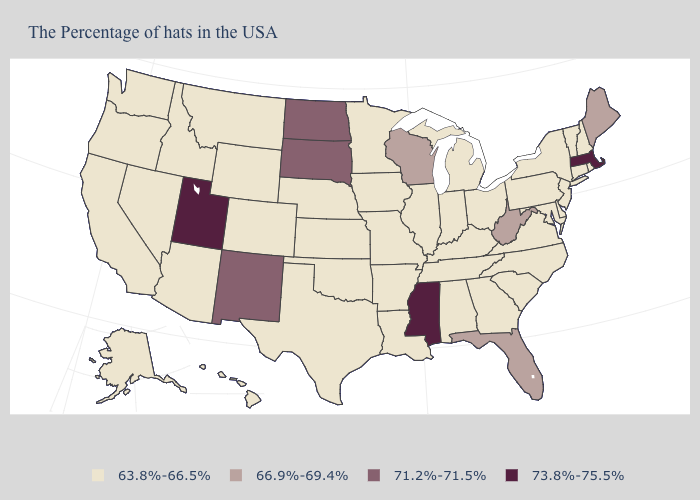What is the value of Nevada?
Quick response, please. 63.8%-66.5%. Name the states that have a value in the range 66.9%-69.4%?
Quick response, please. Maine, West Virginia, Florida, Wisconsin. Name the states that have a value in the range 66.9%-69.4%?
Short answer required. Maine, West Virginia, Florida, Wisconsin. Does New Mexico have the lowest value in the West?
Answer briefly. No. Does the map have missing data?
Quick response, please. No. Name the states that have a value in the range 71.2%-71.5%?
Be succinct. South Dakota, North Dakota, New Mexico. Name the states that have a value in the range 71.2%-71.5%?
Write a very short answer. South Dakota, North Dakota, New Mexico. Does the first symbol in the legend represent the smallest category?
Quick response, please. Yes. What is the lowest value in states that border New Mexico?
Short answer required. 63.8%-66.5%. Among the states that border Rhode Island , which have the highest value?
Write a very short answer. Massachusetts. Is the legend a continuous bar?
Be succinct. No. What is the value of South Dakota?
Keep it brief. 71.2%-71.5%. Name the states that have a value in the range 73.8%-75.5%?
Concise answer only. Massachusetts, Mississippi, Utah. What is the value of Nevada?
Keep it brief. 63.8%-66.5%. What is the lowest value in the USA?
Write a very short answer. 63.8%-66.5%. 